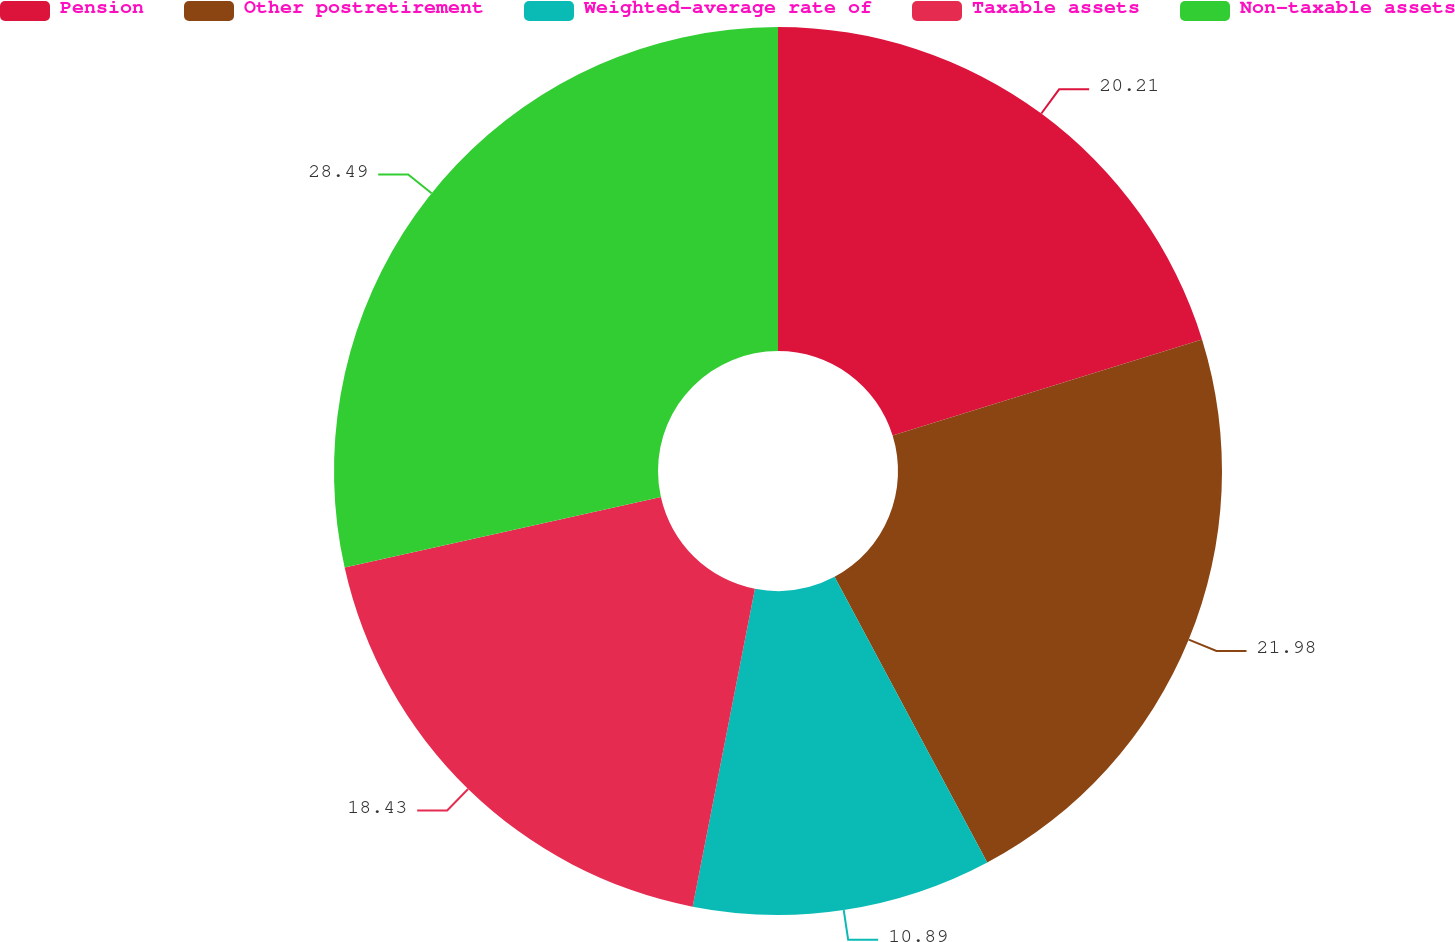Convert chart. <chart><loc_0><loc_0><loc_500><loc_500><pie_chart><fcel>Pension<fcel>Other postretirement<fcel>Weighted-average rate of<fcel>Taxable assets<fcel>Non-taxable assets<nl><fcel>20.21%<fcel>21.98%<fcel>10.89%<fcel>18.43%<fcel>28.49%<nl></chart> 